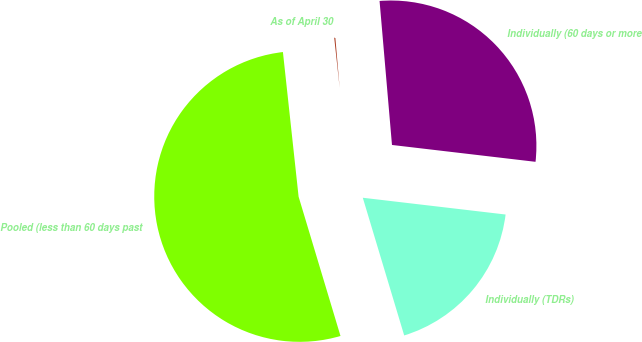Convert chart to OTSL. <chart><loc_0><loc_0><loc_500><loc_500><pie_chart><fcel>As of April 30<fcel>Pooled (less than 60 days past<fcel>Individually (TDRs)<fcel>Individually (60 days or more<nl><fcel>0.35%<fcel>52.93%<fcel>18.49%<fcel>28.23%<nl></chart> 